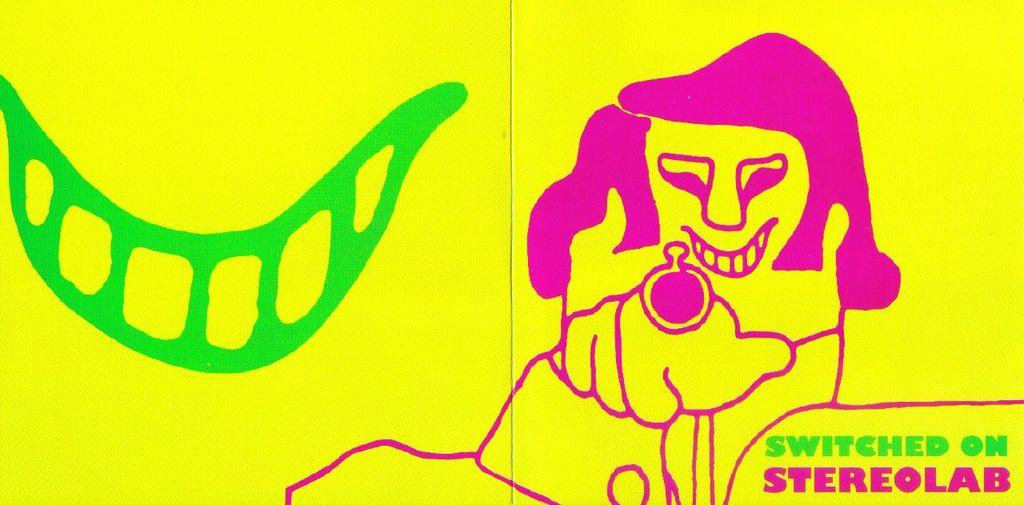What color is the poster in the image? The poster is yellow. What is depicted on the poster? There is a drawing on the poster. Where is the watermark located on the poster? The watermark is on the right side bottom of the poster. What type of paste is used to attach the mitten to the poster? There is no mitten present on the poster, so there is no need for paste. 